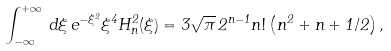<formula> <loc_0><loc_0><loc_500><loc_500>\int _ { - \infty } ^ { + \infty } \, d \xi \, e ^ { - \xi ^ { 2 } } \xi ^ { 4 } H _ { n } ^ { 2 } ( \xi ) = 3 \sqrt { \pi } \, 2 ^ { n - 1 } n ! \left ( n ^ { 2 } + n + 1 / 2 \right ) ,</formula> 